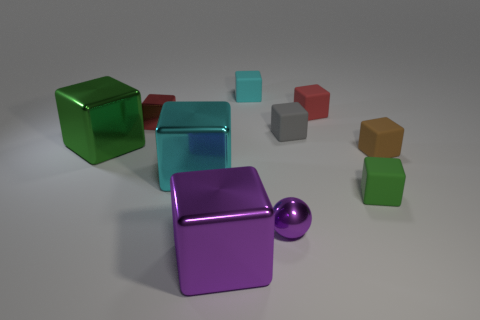Subtract all purple blocks. How many blocks are left? 8 Subtract all blocks. How many objects are left? 1 Subtract all gray balls. How many green blocks are left? 2 Subtract all green blocks. How many blocks are left? 7 Subtract 8 cubes. How many cubes are left? 1 Subtract all brown cubes. Subtract all yellow cylinders. How many cubes are left? 8 Subtract all large green shiny blocks. Subtract all small brown matte things. How many objects are left? 8 Add 2 small red metallic things. How many small red metallic things are left? 3 Add 7 small brown objects. How many small brown objects exist? 8 Subtract 1 purple blocks. How many objects are left? 9 